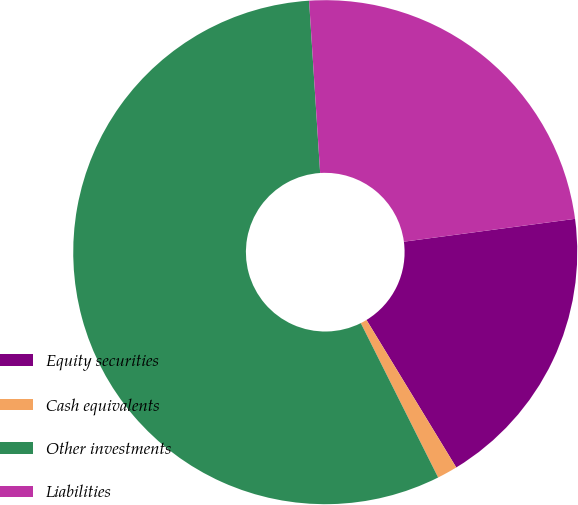Convert chart to OTSL. <chart><loc_0><loc_0><loc_500><loc_500><pie_chart><fcel>Equity securities<fcel>Cash equivalents<fcel>Other investments<fcel>Liabilities<nl><fcel>18.41%<fcel>1.31%<fcel>56.37%<fcel>23.91%<nl></chart> 